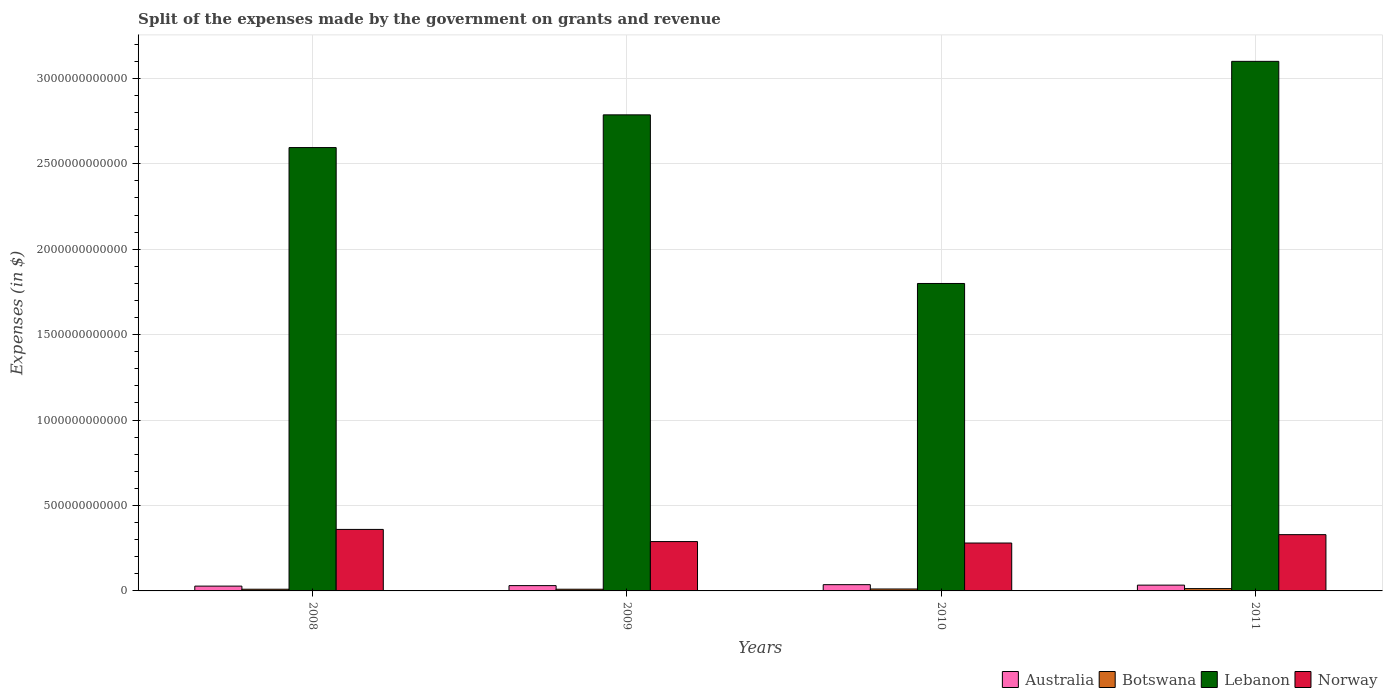How many different coloured bars are there?
Provide a short and direct response. 4. How many groups of bars are there?
Give a very brief answer. 4. How many bars are there on the 4th tick from the left?
Provide a succinct answer. 4. In how many cases, is the number of bars for a given year not equal to the number of legend labels?
Make the answer very short. 0. What is the expenses made by the government on grants and revenue in Lebanon in 2010?
Provide a short and direct response. 1.80e+12. Across all years, what is the maximum expenses made by the government on grants and revenue in Lebanon?
Your answer should be compact. 3.10e+12. Across all years, what is the minimum expenses made by the government on grants and revenue in Lebanon?
Provide a succinct answer. 1.80e+12. In which year was the expenses made by the government on grants and revenue in Australia maximum?
Keep it short and to the point. 2010. What is the total expenses made by the government on grants and revenue in Norway in the graph?
Ensure brevity in your answer.  1.26e+12. What is the difference between the expenses made by the government on grants and revenue in Australia in 2009 and that in 2011?
Provide a succinct answer. -2.88e+09. What is the difference between the expenses made by the government on grants and revenue in Botswana in 2008 and the expenses made by the government on grants and revenue in Norway in 2010?
Give a very brief answer. -2.70e+11. What is the average expenses made by the government on grants and revenue in Australia per year?
Ensure brevity in your answer.  3.24e+1. In the year 2011, what is the difference between the expenses made by the government on grants and revenue in Norway and expenses made by the government on grants and revenue in Botswana?
Offer a terse response. 3.16e+11. In how many years, is the expenses made by the government on grants and revenue in Lebanon greater than 600000000000 $?
Offer a terse response. 4. What is the ratio of the expenses made by the government on grants and revenue in Botswana in 2008 to that in 2009?
Your response must be concise. 1. Is the difference between the expenses made by the government on grants and revenue in Norway in 2010 and 2011 greater than the difference between the expenses made by the government on grants and revenue in Botswana in 2010 and 2011?
Your answer should be very brief. No. What is the difference between the highest and the second highest expenses made by the government on grants and revenue in Botswana?
Your response must be concise. 2.20e+09. What is the difference between the highest and the lowest expenses made by the government on grants and revenue in Botswana?
Provide a succinct answer. 3.66e+09. In how many years, is the expenses made by the government on grants and revenue in Norway greater than the average expenses made by the government on grants and revenue in Norway taken over all years?
Keep it short and to the point. 2. Is it the case that in every year, the sum of the expenses made by the government on grants and revenue in Botswana and expenses made by the government on grants and revenue in Australia is greater than the sum of expenses made by the government on grants and revenue in Norway and expenses made by the government on grants and revenue in Lebanon?
Make the answer very short. Yes. What does the 1st bar from the left in 2011 represents?
Offer a very short reply. Australia. What does the 3rd bar from the right in 2010 represents?
Your answer should be very brief. Botswana. How many bars are there?
Your answer should be compact. 16. What is the difference between two consecutive major ticks on the Y-axis?
Your response must be concise. 5.00e+11. Where does the legend appear in the graph?
Provide a short and direct response. Bottom right. What is the title of the graph?
Provide a succinct answer. Split of the expenses made by the government on grants and revenue. Does "Oman" appear as one of the legend labels in the graph?
Provide a short and direct response. No. What is the label or title of the Y-axis?
Your answer should be very brief. Expenses (in $). What is the Expenses (in $) in Australia in 2008?
Provide a succinct answer. 2.81e+1. What is the Expenses (in $) in Botswana in 2008?
Offer a very short reply. 9.89e+09. What is the Expenses (in $) of Lebanon in 2008?
Offer a very short reply. 2.59e+12. What is the Expenses (in $) in Norway in 2008?
Offer a very short reply. 3.60e+11. What is the Expenses (in $) of Australia in 2009?
Your answer should be compact. 3.10e+1. What is the Expenses (in $) of Botswana in 2009?
Make the answer very short. 9.87e+09. What is the Expenses (in $) of Lebanon in 2009?
Your response must be concise. 2.79e+12. What is the Expenses (in $) in Norway in 2009?
Offer a very short reply. 2.89e+11. What is the Expenses (in $) of Australia in 2010?
Offer a very short reply. 3.67e+1. What is the Expenses (in $) in Botswana in 2010?
Your answer should be very brief. 1.13e+1. What is the Expenses (in $) of Lebanon in 2010?
Your response must be concise. 1.80e+12. What is the Expenses (in $) of Norway in 2010?
Keep it short and to the point. 2.80e+11. What is the Expenses (in $) in Australia in 2011?
Provide a succinct answer. 3.39e+1. What is the Expenses (in $) in Botswana in 2011?
Offer a terse response. 1.35e+1. What is the Expenses (in $) in Lebanon in 2011?
Provide a succinct answer. 3.10e+12. What is the Expenses (in $) of Norway in 2011?
Your answer should be compact. 3.29e+11. Across all years, what is the maximum Expenses (in $) in Australia?
Offer a very short reply. 3.67e+1. Across all years, what is the maximum Expenses (in $) in Botswana?
Your response must be concise. 1.35e+1. Across all years, what is the maximum Expenses (in $) in Lebanon?
Make the answer very short. 3.10e+12. Across all years, what is the maximum Expenses (in $) in Norway?
Offer a very short reply. 3.60e+11. Across all years, what is the minimum Expenses (in $) of Australia?
Make the answer very short. 2.81e+1. Across all years, what is the minimum Expenses (in $) of Botswana?
Provide a short and direct response. 9.87e+09. Across all years, what is the minimum Expenses (in $) of Lebanon?
Make the answer very short. 1.80e+12. Across all years, what is the minimum Expenses (in $) of Norway?
Your answer should be compact. 2.80e+11. What is the total Expenses (in $) of Australia in the graph?
Make the answer very short. 1.30e+11. What is the total Expenses (in $) in Botswana in the graph?
Your answer should be very brief. 4.46e+1. What is the total Expenses (in $) of Lebanon in the graph?
Your response must be concise. 1.03e+13. What is the total Expenses (in $) of Norway in the graph?
Provide a succinct answer. 1.26e+12. What is the difference between the Expenses (in $) of Australia in 2008 and that in 2009?
Give a very brief answer. -2.93e+09. What is the difference between the Expenses (in $) in Botswana in 2008 and that in 2009?
Your answer should be compact. 1.95e+07. What is the difference between the Expenses (in $) of Lebanon in 2008 and that in 2009?
Provide a succinct answer. -1.91e+11. What is the difference between the Expenses (in $) of Norway in 2008 and that in 2009?
Your answer should be very brief. 7.12e+1. What is the difference between the Expenses (in $) in Australia in 2008 and that in 2010?
Offer a very short reply. -8.56e+09. What is the difference between the Expenses (in $) in Botswana in 2008 and that in 2010?
Offer a very short reply. -1.44e+09. What is the difference between the Expenses (in $) of Lebanon in 2008 and that in 2010?
Your response must be concise. 7.95e+11. What is the difference between the Expenses (in $) in Norway in 2008 and that in 2010?
Provide a succinct answer. 7.96e+1. What is the difference between the Expenses (in $) of Australia in 2008 and that in 2011?
Provide a succinct answer. -5.81e+09. What is the difference between the Expenses (in $) in Botswana in 2008 and that in 2011?
Keep it short and to the point. -3.64e+09. What is the difference between the Expenses (in $) in Lebanon in 2008 and that in 2011?
Give a very brief answer. -5.05e+11. What is the difference between the Expenses (in $) in Norway in 2008 and that in 2011?
Your response must be concise. 3.07e+1. What is the difference between the Expenses (in $) of Australia in 2009 and that in 2010?
Provide a short and direct response. -5.63e+09. What is the difference between the Expenses (in $) of Botswana in 2009 and that in 2010?
Offer a terse response. -1.46e+09. What is the difference between the Expenses (in $) of Lebanon in 2009 and that in 2010?
Provide a short and direct response. 9.87e+11. What is the difference between the Expenses (in $) in Norway in 2009 and that in 2010?
Provide a succinct answer. 8.45e+09. What is the difference between the Expenses (in $) in Australia in 2009 and that in 2011?
Your answer should be very brief. -2.88e+09. What is the difference between the Expenses (in $) of Botswana in 2009 and that in 2011?
Make the answer very short. -3.66e+09. What is the difference between the Expenses (in $) in Lebanon in 2009 and that in 2011?
Your answer should be very brief. -3.13e+11. What is the difference between the Expenses (in $) of Norway in 2009 and that in 2011?
Provide a short and direct response. -4.05e+1. What is the difference between the Expenses (in $) in Australia in 2010 and that in 2011?
Provide a succinct answer. 2.75e+09. What is the difference between the Expenses (in $) in Botswana in 2010 and that in 2011?
Provide a short and direct response. -2.20e+09. What is the difference between the Expenses (in $) in Lebanon in 2010 and that in 2011?
Keep it short and to the point. -1.30e+12. What is the difference between the Expenses (in $) of Norway in 2010 and that in 2011?
Make the answer very short. -4.90e+1. What is the difference between the Expenses (in $) of Australia in 2008 and the Expenses (in $) of Botswana in 2009?
Offer a terse response. 1.82e+1. What is the difference between the Expenses (in $) of Australia in 2008 and the Expenses (in $) of Lebanon in 2009?
Give a very brief answer. -2.76e+12. What is the difference between the Expenses (in $) of Australia in 2008 and the Expenses (in $) of Norway in 2009?
Your answer should be compact. -2.61e+11. What is the difference between the Expenses (in $) of Botswana in 2008 and the Expenses (in $) of Lebanon in 2009?
Make the answer very short. -2.78e+12. What is the difference between the Expenses (in $) in Botswana in 2008 and the Expenses (in $) in Norway in 2009?
Provide a succinct answer. -2.79e+11. What is the difference between the Expenses (in $) of Lebanon in 2008 and the Expenses (in $) of Norway in 2009?
Give a very brief answer. 2.31e+12. What is the difference between the Expenses (in $) in Australia in 2008 and the Expenses (in $) in Botswana in 2010?
Your answer should be very brief. 1.68e+1. What is the difference between the Expenses (in $) of Australia in 2008 and the Expenses (in $) of Lebanon in 2010?
Your response must be concise. -1.77e+12. What is the difference between the Expenses (in $) of Australia in 2008 and the Expenses (in $) of Norway in 2010?
Give a very brief answer. -2.52e+11. What is the difference between the Expenses (in $) in Botswana in 2008 and the Expenses (in $) in Lebanon in 2010?
Offer a very short reply. -1.79e+12. What is the difference between the Expenses (in $) of Botswana in 2008 and the Expenses (in $) of Norway in 2010?
Provide a short and direct response. -2.70e+11. What is the difference between the Expenses (in $) in Lebanon in 2008 and the Expenses (in $) in Norway in 2010?
Your answer should be very brief. 2.31e+12. What is the difference between the Expenses (in $) in Australia in 2008 and the Expenses (in $) in Botswana in 2011?
Ensure brevity in your answer.  1.46e+1. What is the difference between the Expenses (in $) in Australia in 2008 and the Expenses (in $) in Lebanon in 2011?
Keep it short and to the point. -3.07e+12. What is the difference between the Expenses (in $) in Australia in 2008 and the Expenses (in $) in Norway in 2011?
Give a very brief answer. -3.01e+11. What is the difference between the Expenses (in $) of Botswana in 2008 and the Expenses (in $) of Lebanon in 2011?
Give a very brief answer. -3.09e+12. What is the difference between the Expenses (in $) in Botswana in 2008 and the Expenses (in $) in Norway in 2011?
Ensure brevity in your answer.  -3.19e+11. What is the difference between the Expenses (in $) in Lebanon in 2008 and the Expenses (in $) in Norway in 2011?
Your answer should be compact. 2.27e+12. What is the difference between the Expenses (in $) of Australia in 2009 and the Expenses (in $) of Botswana in 2010?
Keep it short and to the point. 1.97e+1. What is the difference between the Expenses (in $) of Australia in 2009 and the Expenses (in $) of Lebanon in 2010?
Offer a terse response. -1.77e+12. What is the difference between the Expenses (in $) in Australia in 2009 and the Expenses (in $) in Norway in 2010?
Keep it short and to the point. -2.49e+11. What is the difference between the Expenses (in $) in Botswana in 2009 and the Expenses (in $) in Lebanon in 2010?
Ensure brevity in your answer.  -1.79e+12. What is the difference between the Expenses (in $) in Botswana in 2009 and the Expenses (in $) in Norway in 2010?
Offer a terse response. -2.70e+11. What is the difference between the Expenses (in $) of Lebanon in 2009 and the Expenses (in $) of Norway in 2010?
Your answer should be compact. 2.51e+12. What is the difference between the Expenses (in $) of Australia in 2009 and the Expenses (in $) of Botswana in 2011?
Your answer should be compact. 1.75e+1. What is the difference between the Expenses (in $) of Australia in 2009 and the Expenses (in $) of Lebanon in 2011?
Offer a terse response. -3.07e+12. What is the difference between the Expenses (in $) in Australia in 2009 and the Expenses (in $) in Norway in 2011?
Provide a short and direct response. -2.98e+11. What is the difference between the Expenses (in $) in Botswana in 2009 and the Expenses (in $) in Lebanon in 2011?
Give a very brief answer. -3.09e+12. What is the difference between the Expenses (in $) in Botswana in 2009 and the Expenses (in $) in Norway in 2011?
Give a very brief answer. -3.19e+11. What is the difference between the Expenses (in $) in Lebanon in 2009 and the Expenses (in $) in Norway in 2011?
Offer a very short reply. 2.46e+12. What is the difference between the Expenses (in $) of Australia in 2010 and the Expenses (in $) of Botswana in 2011?
Provide a succinct answer. 2.31e+1. What is the difference between the Expenses (in $) in Australia in 2010 and the Expenses (in $) in Lebanon in 2011?
Provide a short and direct response. -3.06e+12. What is the difference between the Expenses (in $) in Australia in 2010 and the Expenses (in $) in Norway in 2011?
Keep it short and to the point. -2.93e+11. What is the difference between the Expenses (in $) in Botswana in 2010 and the Expenses (in $) in Lebanon in 2011?
Make the answer very short. -3.09e+12. What is the difference between the Expenses (in $) in Botswana in 2010 and the Expenses (in $) in Norway in 2011?
Ensure brevity in your answer.  -3.18e+11. What is the difference between the Expenses (in $) of Lebanon in 2010 and the Expenses (in $) of Norway in 2011?
Offer a very short reply. 1.47e+12. What is the average Expenses (in $) in Australia per year?
Keep it short and to the point. 3.24e+1. What is the average Expenses (in $) of Botswana per year?
Give a very brief answer. 1.12e+1. What is the average Expenses (in $) in Lebanon per year?
Make the answer very short. 2.57e+12. What is the average Expenses (in $) in Norway per year?
Provide a succinct answer. 3.15e+11. In the year 2008, what is the difference between the Expenses (in $) of Australia and Expenses (in $) of Botswana?
Give a very brief answer. 1.82e+1. In the year 2008, what is the difference between the Expenses (in $) of Australia and Expenses (in $) of Lebanon?
Provide a short and direct response. -2.57e+12. In the year 2008, what is the difference between the Expenses (in $) of Australia and Expenses (in $) of Norway?
Provide a short and direct response. -3.32e+11. In the year 2008, what is the difference between the Expenses (in $) of Botswana and Expenses (in $) of Lebanon?
Ensure brevity in your answer.  -2.59e+12. In the year 2008, what is the difference between the Expenses (in $) in Botswana and Expenses (in $) in Norway?
Your answer should be compact. -3.50e+11. In the year 2008, what is the difference between the Expenses (in $) in Lebanon and Expenses (in $) in Norway?
Provide a succinct answer. 2.23e+12. In the year 2009, what is the difference between the Expenses (in $) in Australia and Expenses (in $) in Botswana?
Your response must be concise. 2.11e+1. In the year 2009, what is the difference between the Expenses (in $) in Australia and Expenses (in $) in Lebanon?
Make the answer very short. -2.76e+12. In the year 2009, what is the difference between the Expenses (in $) in Australia and Expenses (in $) in Norway?
Offer a terse response. -2.58e+11. In the year 2009, what is the difference between the Expenses (in $) of Botswana and Expenses (in $) of Lebanon?
Provide a succinct answer. -2.78e+12. In the year 2009, what is the difference between the Expenses (in $) of Botswana and Expenses (in $) of Norway?
Provide a succinct answer. -2.79e+11. In the year 2009, what is the difference between the Expenses (in $) in Lebanon and Expenses (in $) in Norway?
Make the answer very short. 2.50e+12. In the year 2010, what is the difference between the Expenses (in $) of Australia and Expenses (in $) of Botswana?
Your answer should be compact. 2.53e+1. In the year 2010, what is the difference between the Expenses (in $) of Australia and Expenses (in $) of Lebanon?
Your answer should be compact. -1.76e+12. In the year 2010, what is the difference between the Expenses (in $) in Australia and Expenses (in $) in Norway?
Your answer should be compact. -2.44e+11. In the year 2010, what is the difference between the Expenses (in $) of Botswana and Expenses (in $) of Lebanon?
Your response must be concise. -1.79e+12. In the year 2010, what is the difference between the Expenses (in $) of Botswana and Expenses (in $) of Norway?
Your response must be concise. -2.69e+11. In the year 2010, what is the difference between the Expenses (in $) in Lebanon and Expenses (in $) in Norway?
Your answer should be very brief. 1.52e+12. In the year 2011, what is the difference between the Expenses (in $) in Australia and Expenses (in $) in Botswana?
Give a very brief answer. 2.04e+1. In the year 2011, what is the difference between the Expenses (in $) of Australia and Expenses (in $) of Lebanon?
Provide a succinct answer. -3.07e+12. In the year 2011, what is the difference between the Expenses (in $) in Australia and Expenses (in $) in Norway?
Ensure brevity in your answer.  -2.95e+11. In the year 2011, what is the difference between the Expenses (in $) in Botswana and Expenses (in $) in Lebanon?
Give a very brief answer. -3.09e+12. In the year 2011, what is the difference between the Expenses (in $) in Botswana and Expenses (in $) in Norway?
Provide a succinct answer. -3.16e+11. In the year 2011, what is the difference between the Expenses (in $) of Lebanon and Expenses (in $) of Norway?
Give a very brief answer. 2.77e+12. What is the ratio of the Expenses (in $) of Australia in 2008 to that in 2009?
Your answer should be very brief. 0.91. What is the ratio of the Expenses (in $) of Botswana in 2008 to that in 2009?
Your answer should be very brief. 1. What is the ratio of the Expenses (in $) of Lebanon in 2008 to that in 2009?
Provide a short and direct response. 0.93. What is the ratio of the Expenses (in $) of Norway in 2008 to that in 2009?
Provide a short and direct response. 1.25. What is the ratio of the Expenses (in $) in Australia in 2008 to that in 2010?
Ensure brevity in your answer.  0.77. What is the ratio of the Expenses (in $) in Botswana in 2008 to that in 2010?
Offer a very short reply. 0.87. What is the ratio of the Expenses (in $) of Lebanon in 2008 to that in 2010?
Offer a terse response. 1.44. What is the ratio of the Expenses (in $) in Norway in 2008 to that in 2010?
Your response must be concise. 1.28. What is the ratio of the Expenses (in $) of Australia in 2008 to that in 2011?
Your answer should be compact. 0.83. What is the ratio of the Expenses (in $) of Botswana in 2008 to that in 2011?
Keep it short and to the point. 0.73. What is the ratio of the Expenses (in $) in Lebanon in 2008 to that in 2011?
Your answer should be very brief. 0.84. What is the ratio of the Expenses (in $) in Norway in 2008 to that in 2011?
Your answer should be compact. 1.09. What is the ratio of the Expenses (in $) in Australia in 2009 to that in 2010?
Offer a terse response. 0.85. What is the ratio of the Expenses (in $) in Botswana in 2009 to that in 2010?
Your response must be concise. 0.87. What is the ratio of the Expenses (in $) in Lebanon in 2009 to that in 2010?
Give a very brief answer. 1.55. What is the ratio of the Expenses (in $) of Norway in 2009 to that in 2010?
Offer a terse response. 1.03. What is the ratio of the Expenses (in $) in Australia in 2009 to that in 2011?
Provide a short and direct response. 0.92. What is the ratio of the Expenses (in $) of Botswana in 2009 to that in 2011?
Provide a short and direct response. 0.73. What is the ratio of the Expenses (in $) of Lebanon in 2009 to that in 2011?
Make the answer very short. 0.9. What is the ratio of the Expenses (in $) in Norway in 2009 to that in 2011?
Provide a short and direct response. 0.88. What is the ratio of the Expenses (in $) in Australia in 2010 to that in 2011?
Give a very brief answer. 1.08. What is the ratio of the Expenses (in $) in Botswana in 2010 to that in 2011?
Your response must be concise. 0.84. What is the ratio of the Expenses (in $) in Lebanon in 2010 to that in 2011?
Provide a succinct answer. 0.58. What is the ratio of the Expenses (in $) in Norway in 2010 to that in 2011?
Provide a short and direct response. 0.85. What is the difference between the highest and the second highest Expenses (in $) in Australia?
Your answer should be compact. 2.75e+09. What is the difference between the highest and the second highest Expenses (in $) of Botswana?
Keep it short and to the point. 2.20e+09. What is the difference between the highest and the second highest Expenses (in $) in Lebanon?
Offer a very short reply. 3.13e+11. What is the difference between the highest and the second highest Expenses (in $) in Norway?
Your answer should be very brief. 3.07e+1. What is the difference between the highest and the lowest Expenses (in $) of Australia?
Make the answer very short. 8.56e+09. What is the difference between the highest and the lowest Expenses (in $) of Botswana?
Give a very brief answer. 3.66e+09. What is the difference between the highest and the lowest Expenses (in $) of Lebanon?
Give a very brief answer. 1.30e+12. What is the difference between the highest and the lowest Expenses (in $) in Norway?
Offer a very short reply. 7.96e+1. 